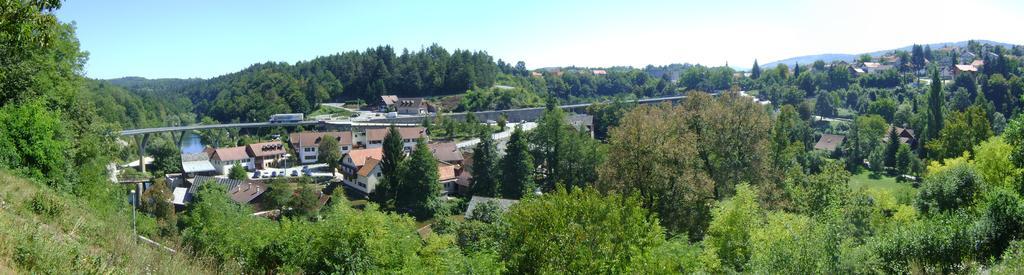How would you summarize this image in a sentence or two? In this image I can see trees in green color, at the background I can see few buildings in cream and white color, sky in blue and white color. 